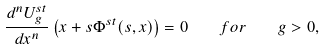Convert formula to latex. <formula><loc_0><loc_0><loc_500><loc_500>\frac { d ^ { n } U _ { g } ^ { s t } } { d x ^ { n } } \left ( x + s \Phi ^ { s t } ( s , x ) \right ) = 0 \quad f o r \quad g > 0 ,</formula> 